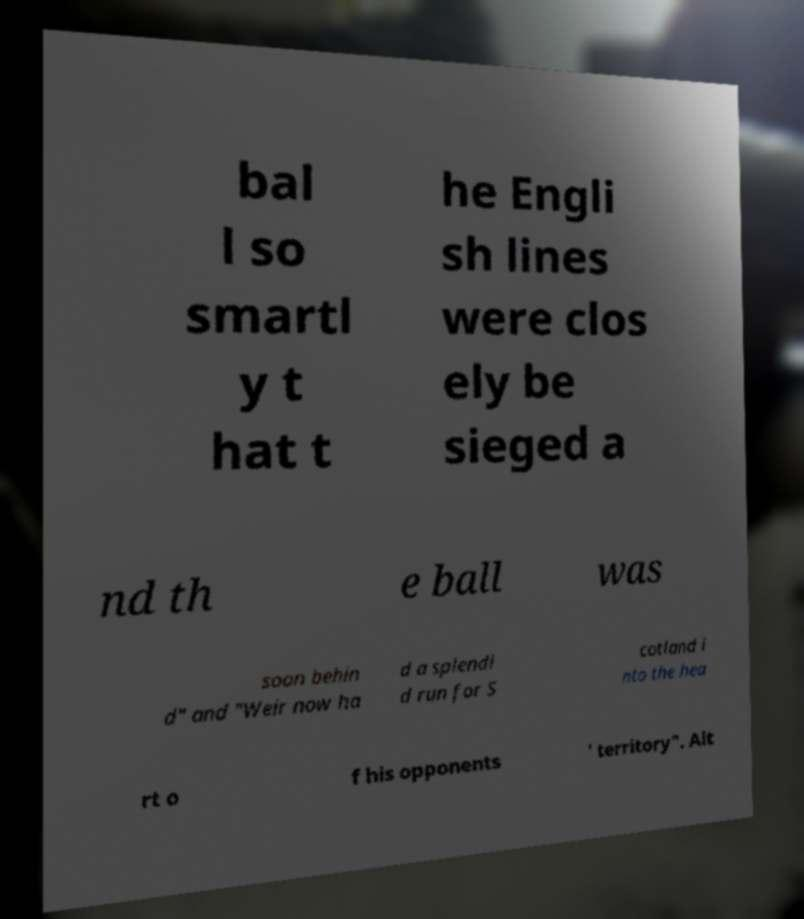What messages or text are displayed in this image? I need them in a readable, typed format. bal l so smartl y t hat t he Engli sh lines were clos ely be sieged a nd th e ball was soon behin d" and "Weir now ha d a splendi d run for S cotland i nto the hea rt o f his opponents ' territory". Alt 